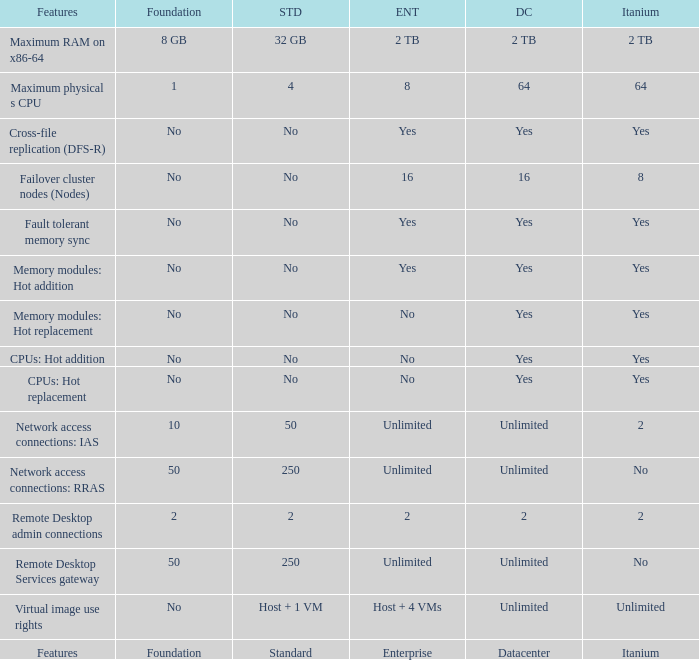What is the Datacenter for the Memory modules: hot addition Feature that has Yes listed for Itanium? Yes. 